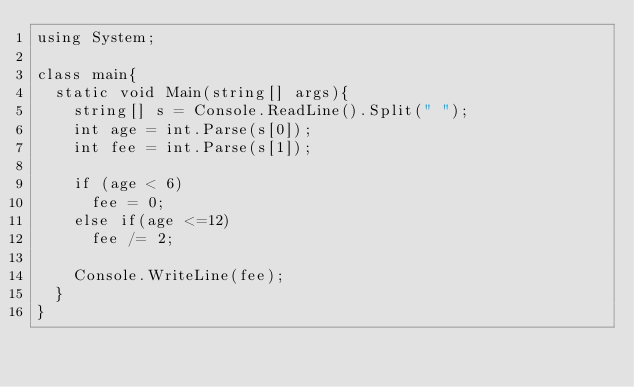<code> <loc_0><loc_0><loc_500><loc_500><_C#_>using System;
 
class main{
  static void Main(string[] args){
    string[] s = Console.ReadLine().Split(" ");
    int age = int.Parse(s[0]);
    int fee = int.Parse(s[1]);
    
    if (age < 6)
      fee = 0;
    else if(age <=12)
      fee /= 2;
    
    Console.WriteLine(fee);
  }
}</code> 